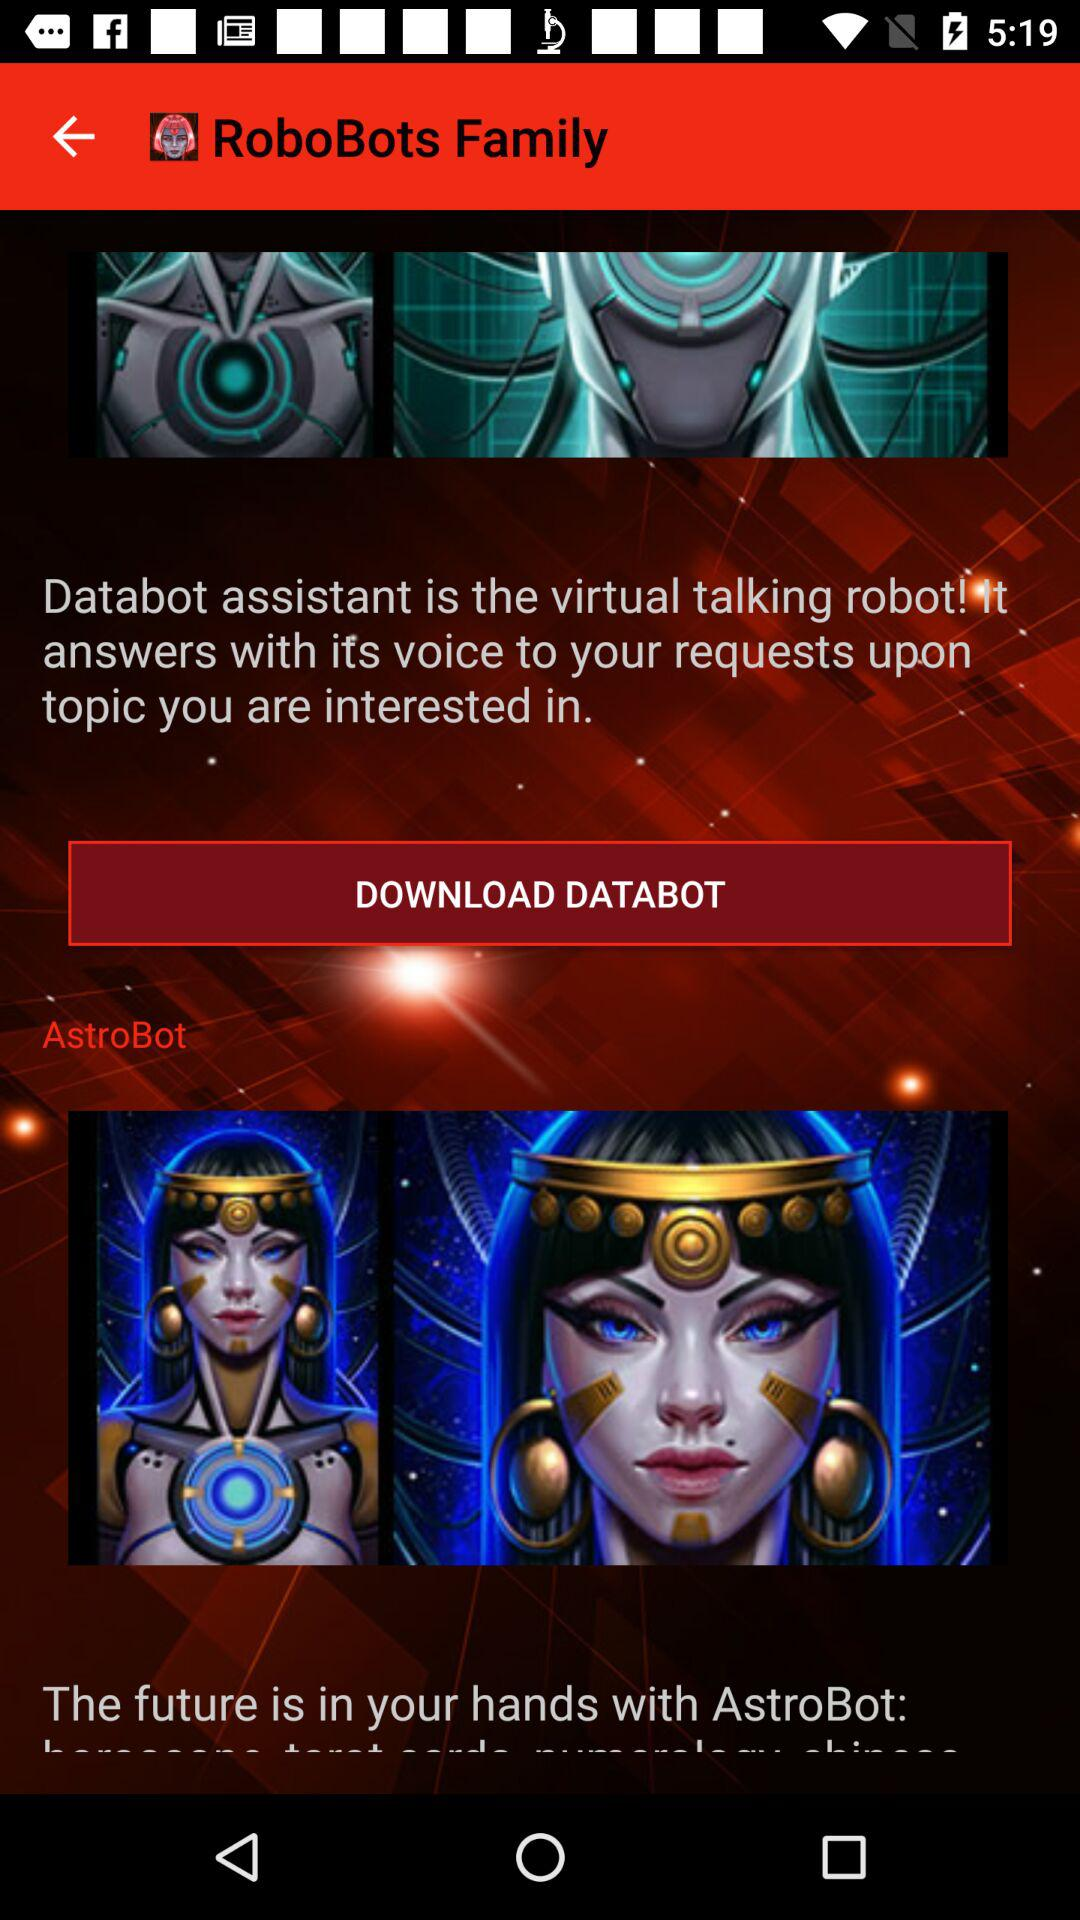Who is the virtual talking robot? It is "Databot assistant". 